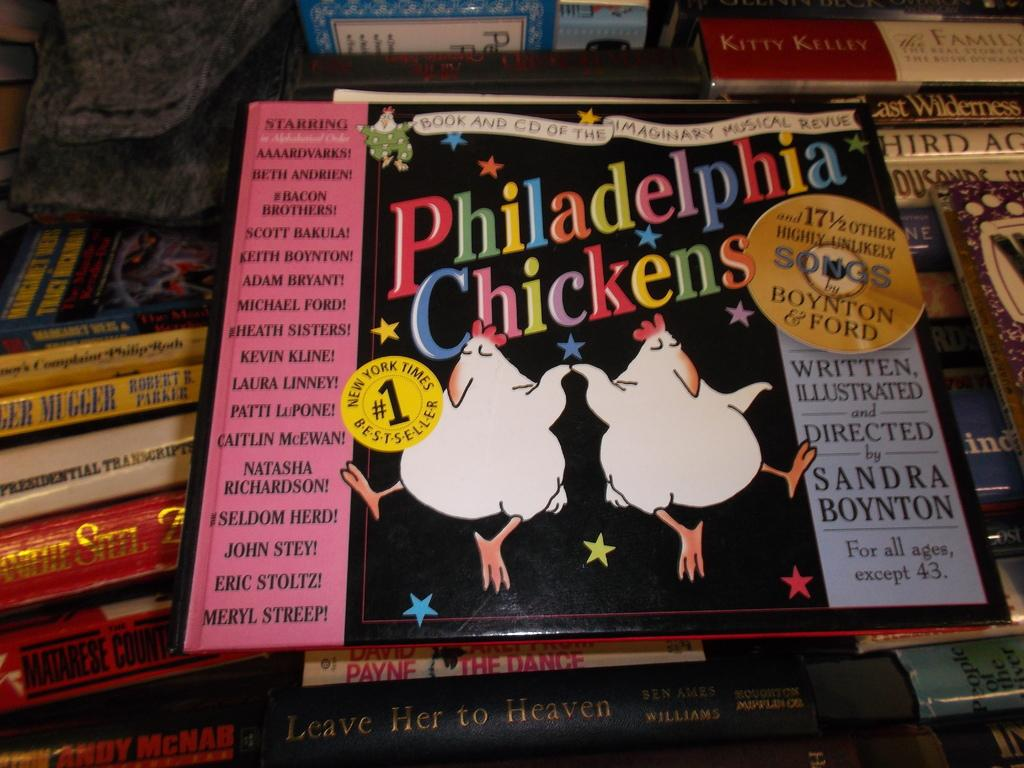Provide a one-sentence caption for the provided image. Two dancing chickens grace the gover a a book titled Philadelphia Chickens. 